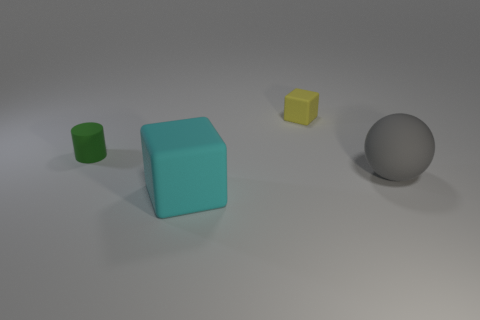What material do the objects in the image appear to be made of? The objects in the image have a matte finish and consistent shading which suggests they are made of a solid, non-reflective material, likely a type of plastic commonly used in models or 3D renderings. 